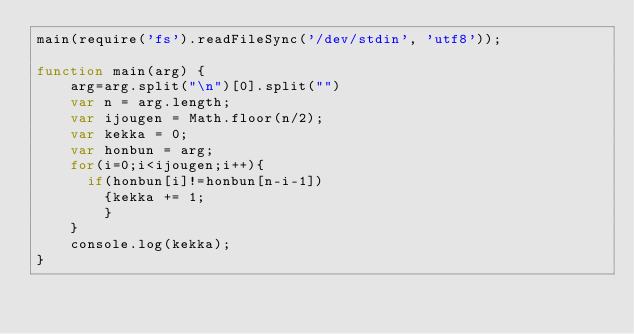Convert code to text. <code><loc_0><loc_0><loc_500><loc_500><_JavaScript_>main(require('fs').readFileSync('/dev/stdin', 'utf8'));

function main(arg) {
    arg=arg.split("\n")[0].split("")
    var n = arg.length;
    var ijougen = Math.floor(n/2);
    var kekka = 0;
    var honbun = arg;
    for(i=0;i<ijougen;i++){
    	if(honbun[i]!=honbun[n-i-1])
        {kekka += 1;
        }
    }
    console.log(kekka);
}

</code> 